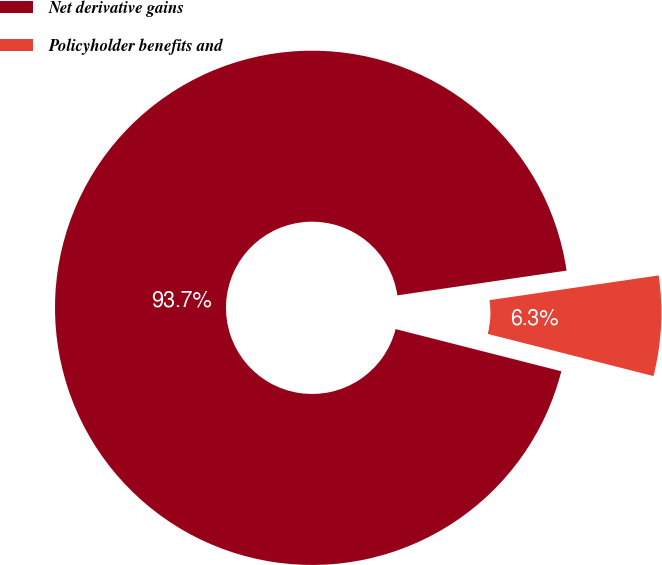Convert chart to OTSL. <chart><loc_0><loc_0><loc_500><loc_500><pie_chart><fcel>Net derivative gains<fcel>Policyholder benefits and<nl><fcel>93.72%<fcel>6.28%<nl></chart> 